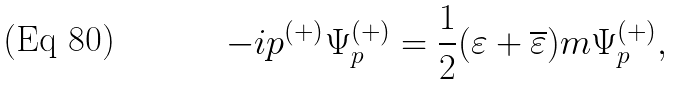Convert formula to latex. <formula><loc_0><loc_0><loc_500><loc_500>- i p ^ { ( + ) } \Psi _ { p } ^ { ( + ) } = \frac { 1 } { 2 } ( \varepsilon + \overline { \varepsilon } ) m \Psi _ { p } ^ { ( + ) } ,</formula> 